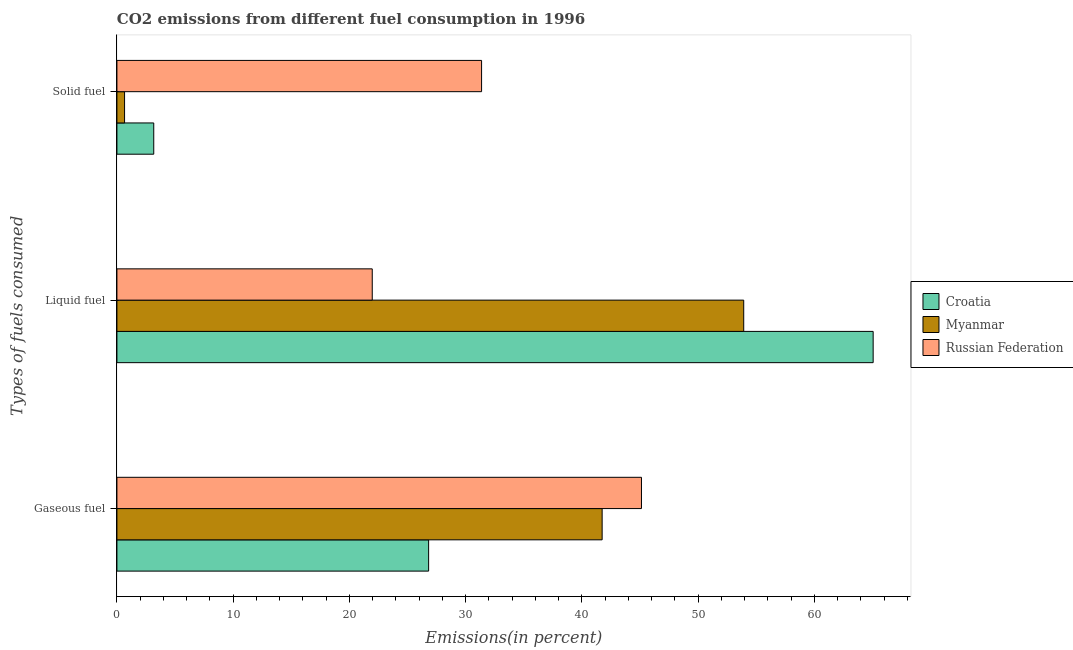How many different coloured bars are there?
Give a very brief answer. 3. Are the number of bars on each tick of the Y-axis equal?
Ensure brevity in your answer.  Yes. How many bars are there on the 1st tick from the top?
Provide a succinct answer. 3. How many bars are there on the 2nd tick from the bottom?
Keep it short and to the point. 3. What is the label of the 1st group of bars from the top?
Give a very brief answer. Solid fuel. What is the percentage of gaseous fuel emission in Myanmar?
Your answer should be compact. 41.74. Across all countries, what is the maximum percentage of solid fuel emission?
Ensure brevity in your answer.  31.37. Across all countries, what is the minimum percentage of gaseous fuel emission?
Provide a succinct answer. 26.81. In which country was the percentage of liquid fuel emission maximum?
Ensure brevity in your answer.  Croatia. In which country was the percentage of gaseous fuel emission minimum?
Make the answer very short. Croatia. What is the total percentage of liquid fuel emission in the graph?
Provide a short and direct response. 140.93. What is the difference between the percentage of solid fuel emission in Croatia and that in Russian Federation?
Ensure brevity in your answer.  -28.2. What is the difference between the percentage of gaseous fuel emission in Russian Federation and the percentage of liquid fuel emission in Myanmar?
Keep it short and to the point. -8.8. What is the average percentage of liquid fuel emission per country?
Make the answer very short. 46.98. What is the difference between the percentage of gaseous fuel emission and percentage of liquid fuel emission in Myanmar?
Keep it short and to the point. -12.18. What is the ratio of the percentage of gaseous fuel emission in Croatia to that in Russian Federation?
Keep it short and to the point. 0.59. What is the difference between the highest and the second highest percentage of gaseous fuel emission?
Offer a terse response. 3.38. What is the difference between the highest and the lowest percentage of liquid fuel emission?
Offer a terse response. 43.09. Is the sum of the percentage of gaseous fuel emission in Myanmar and Russian Federation greater than the maximum percentage of solid fuel emission across all countries?
Offer a terse response. Yes. What does the 3rd bar from the top in Liquid fuel represents?
Provide a short and direct response. Croatia. What does the 2nd bar from the bottom in Gaseous fuel represents?
Make the answer very short. Myanmar. Is it the case that in every country, the sum of the percentage of gaseous fuel emission and percentage of liquid fuel emission is greater than the percentage of solid fuel emission?
Your answer should be very brief. Yes. How many bars are there?
Your response must be concise. 9. Are all the bars in the graph horizontal?
Offer a terse response. Yes. Are the values on the major ticks of X-axis written in scientific E-notation?
Keep it short and to the point. No. Does the graph contain any zero values?
Ensure brevity in your answer.  No. Does the graph contain grids?
Your answer should be very brief. No. How many legend labels are there?
Offer a very short reply. 3. What is the title of the graph?
Your response must be concise. CO2 emissions from different fuel consumption in 1996. Does "Switzerland" appear as one of the legend labels in the graph?
Provide a short and direct response. No. What is the label or title of the X-axis?
Offer a very short reply. Emissions(in percent). What is the label or title of the Y-axis?
Ensure brevity in your answer.  Types of fuels consumed. What is the Emissions(in percent) in Croatia in Gaseous fuel?
Provide a short and direct response. 26.81. What is the Emissions(in percent) of Myanmar in Gaseous fuel?
Give a very brief answer. 41.74. What is the Emissions(in percent) in Russian Federation in Gaseous fuel?
Provide a succinct answer. 45.12. What is the Emissions(in percent) in Croatia in Liquid fuel?
Offer a very short reply. 65.05. What is the Emissions(in percent) of Myanmar in Liquid fuel?
Provide a succinct answer. 53.92. What is the Emissions(in percent) in Russian Federation in Liquid fuel?
Keep it short and to the point. 21.96. What is the Emissions(in percent) of Croatia in Solid fuel?
Give a very brief answer. 3.17. What is the Emissions(in percent) of Myanmar in Solid fuel?
Provide a succinct answer. 0.66. What is the Emissions(in percent) of Russian Federation in Solid fuel?
Offer a very short reply. 31.37. Across all Types of fuels consumed, what is the maximum Emissions(in percent) in Croatia?
Provide a succinct answer. 65.05. Across all Types of fuels consumed, what is the maximum Emissions(in percent) of Myanmar?
Keep it short and to the point. 53.92. Across all Types of fuels consumed, what is the maximum Emissions(in percent) of Russian Federation?
Keep it short and to the point. 45.12. Across all Types of fuels consumed, what is the minimum Emissions(in percent) of Croatia?
Your response must be concise. 3.17. Across all Types of fuels consumed, what is the minimum Emissions(in percent) of Myanmar?
Your answer should be compact. 0.66. Across all Types of fuels consumed, what is the minimum Emissions(in percent) of Russian Federation?
Ensure brevity in your answer.  21.96. What is the total Emissions(in percent) of Croatia in the graph?
Offer a terse response. 95.03. What is the total Emissions(in percent) of Myanmar in the graph?
Give a very brief answer. 96.31. What is the total Emissions(in percent) in Russian Federation in the graph?
Give a very brief answer. 98.45. What is the difference between the Emissions(in percent) of Croatia in Gaseous fuel and that in Liquid fuel?
Make the answer very short. -38.24. What is the difference between the Emissions(in percent) of Myanmar in Gaseous fuel and that in Liquid fuel?
Keep it short and to the point. -12.18. What is the difference between the Emissions(in percent) in Russian Federation in Gaseous fuel and that in Liquid fuel?
Provide a succinct answer. 23.16. What is the difference between the Emissions(in percent) in Croatia in Gaseous fuel and that in Solid fuel?
Offer a terse response. 23.64. What is the difference between the Emissions(in percent) of Myanmar in Gaseous fuel and that in Solid fuel?
Your answer should be compact. 41.08. What is the difference between the Emissions(in percent) in Russian Federation in Gaseous fuel and that in Solid fuel?
Keep it short and to the point. 13.75. What is the difference between the Emissions(in percent) in Croatia in Liquid fuel and that in Solid fuel?
Offer a very short reply. 61.88. What is the difference between the Emissions(in percent) of Myanmar in Liquid fuel and that in Solid fuel?
Provide a succinct answer. 53.26. What is the difference between the Emissions(in percent) of Russian Federation in Liquid fuel and that in Solid fuel?
Offer a very short reply. -9.4. What is the difference between the Emissions(in percent) of Croatia in Gaseous fuel and the Emissions(in percent) of Myanmar in Liquid fuel?
Offer a very short reply. -27.1. What is the difference between the Emissions(in percent) in Croatia in Gaseous fuel and the Emissions(in percent) in Russian Federation in Liquid fuel?
Provide a succinct answer. 4.85. What is the difference between the Emissions(in percent) of Myanmar in Gaseous fuel and the Emissions(in percent) of Russian Federation in Liquid fuel?
Ensure brevity in your answer.  19.77. What is the difference between the Emissions(in percent) of Croatia in Gaseous fuel and the Emissions(in percent) of Myanmar in Solid fuel?
Your answer should be compact. 26.16. What is the difference between the Emissions(in percent) of Croatia in Gaseous fuel and the Emissions(in percent) of Russian Federation in Solid fuel?
Offer a terse response. -4.56. What is the difference between the Emissions(in percent) of Myanmar in Gaseous fuel and the Emissions(in percent) of Russian Federation in Solid fuel?
Provide a succinct answer. 10.37. What is the difference between the Emissions(in percent) in Croatia in Liquid fuel and the Emissions(in percent) in Myanmar in Solid fuel?
Offer a very short reply. 64.39. What is the difference between the Emissions(in percent) in Croatia in Liquid fuel and the Emissions(in percent) in Russian Federation in Solid fuel?
Your response must be concise. 33.68. What is the difference between the Emissions(in percent) in Myanmar in Liquid fuel and the Emissions(in percent) in Russian Federation in Solid fuel?
Ensure brevity in your answer.  22.55. What is the average Emissions(in percent) in Croatia per Types of fuels consumed?
Ensure brevity in your answer.  31.68. What is the average Emissions(in percent) in Myanmar per Types of fuels consumed?
Keep it short and to the point. 32.1. What is the average Emissions(in percent) in Russian Federation per Types of fuels consumed?
Keep it short and to the point. 32.82. What is the difference between the Emissions(in percent) in Croatia and Emissions(in percent) in Myanmar in Gaseous fuel?
Provide a short and direct response. -14.93. What is the difference between the Emissions(in percent) of Croatia and Emissions(in percent) of Russian Federation in Gaseous fuel?
Provide a short and direct response. -18.31. What is the difference between the Emissions(in percent) in Myanmar and Emissions(in percent) in Russian Federation in Gaseous fuel?
Give a very brief answer. -3.38. What is the difference between the Emissions(in percent) in Croatia and Emissions(in percent) in Myanmar in Liquid fuel?
Ensure brevity in your answer.  11.13. What is the difference between the Emissions(in percent) in Croatia and Emissions(in percent) in Russian Federation in Liquid fuel?
Keep it short and to the point. 43.09. What is the difference between the Emissions(in percent) of Myanmar and Emissions(in percent) of Russian Federation in Liquid fuel?
Your response must be concise. 31.95. What is the difference between the Emissions(in percent) in Croatia and Emissions(in percent) in Myanmar in Solid fuel?
Offer a very short reply. 2.51. What is the difference between the Emissions(in percent) of Croatia and Emissions(in percent) of Russian Federation in Solid fuel?
Provide a succinct answer. -28.2. What is the difference between the Emissions(in percent) of Myanmar and Emissions(in percent) of Russian Federation in Solid fuel?
Make the answer very short. -30.71. What is the ratio of the Emissions(in percent) in Croatia in Gaseous fuel to that in Liquid fuel?
Your response must be concise. 0.41. What is the ratio of the Emissions(in percent) in Myanmar in Gaseous fuel to that in Liquid fuel?
Give a very brief answer. 0.77. What is the ratio of the Emissions(in percent) of Russian Federation in Gaseous fuel to that in Liquid fuel?
Your answer should be very brief. 2.05. What is the ratio of the Emissions(in percent) in Croatia in Gaseous fuel to that in Solid fuel?
Keep it short and to the point. 8.46. What is the ratio of the Emissions(in percent) in Myanmar in Gaseous fuel to that in Solid fuel?
Offer a terse response. 63.54. What is the ratio of the Emissions(in percent) in Russian Federation in Gaseous fuel to that in Solid fuel?
Your answer should be compact. 1.44. What is the ratio of the Emissions(in percent) in Croatia in Liquid fuel to that in Solid fuel?
Your answer should be very brief. 20.53. What is the ratio of the Emissions(in percent) in Myanmar in Liquid fuel to that in Solid fuel?
Make the answer very short. 82.08. What is the ratio of the Emissions(in percent) of Russian Federation in Liquid fuel to that in Solid fuel?
Give a very brief answer. 0.7. What is the difference between the highest and the second highest Emissions(in percent) in Croatia?
Keep it short and to the point. 38.24. What is the difference between the highest and the second highest Emissions(in percent) in Myanmar?
Provide a succinct answer. 12.18. What is the difference between the highest and the second highest Emissions(in percent) in Russian Federation?
Make the answer very short. 13.75. What is the difference between the highest and the lowest Emissions(in percent) in Croatia?
Provide a short and direct response. 61.88. What is the difference between the highest and the lowest Emissions(in percent) in Myanmar?
Give a very brief answer. 53.26. What is the difference between the highest and the lowest Emissions(in percent) of Russian Federation?
Ensure brevity in your answer.  23.16. 